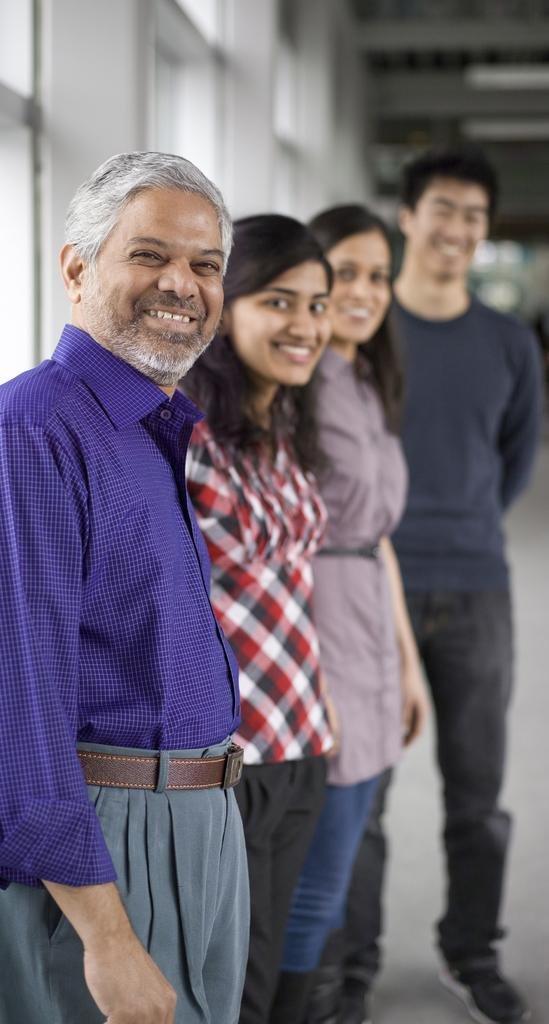What is the main subject of the image? The main subject of the image is a group of persons. Where are the persons located in the image? The persons are in the center of the image. What are the persons doing in the image? The persons are standing and smiling. Can you describe the background of the image? The background of the image is blurry. What type of brick can be seen in the image? There is no brick present in the image. How does the sponge contribute to the overall composition of the image? There is no sponge present in the image. 